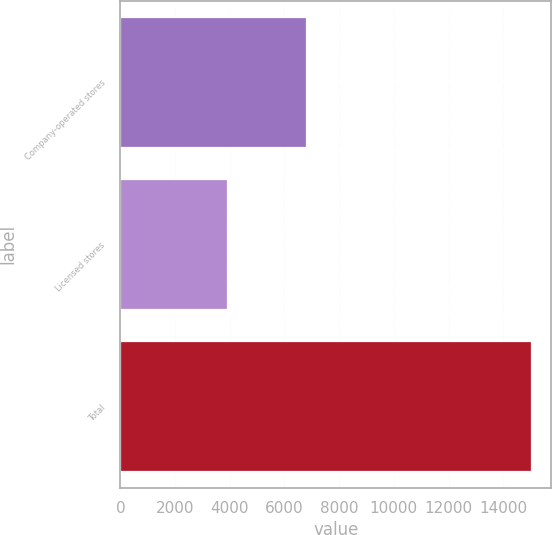Convert chart to OTSL. <chart><loc_0><loc_0><loc_500><loc_500><bar_chart><fcel>Company-operated stores<fcel>Licensed stores<fcel>Total<nl><fcel>6793<fcel>3891<fcel>15011<nl></chart> 